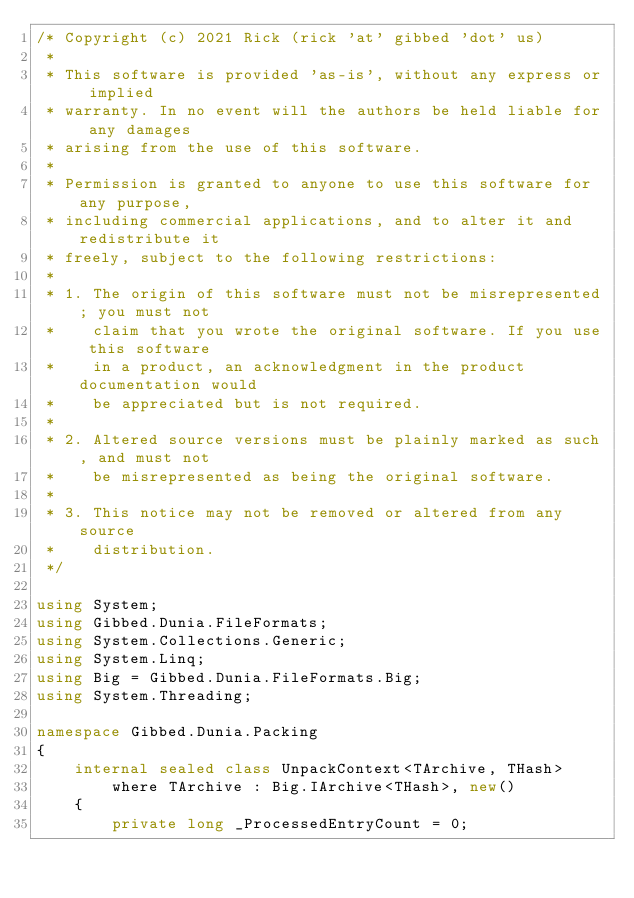<code> <loc_0><loc_0><loc_500><loc_500><_C#_>/* Copyright (c) 2021 Rick (rick 'at' gibbed 'dot' us)
 *
 * This software is provided 'as-is', without any express or implied
 * warranty. In no event will the authors be held liable for any damages
 * arising from the use of this software.
 *
 * Permission is granted to anyone to use this software for any purpose,
 * including commercial applications, and to alter it and redistribute it
 * freely, subject to the following restrictions:
 *
 * 1. The origin of this software must not be misrepresented; you must not
 *    claim that you wrote the original software. If you use this software
 *    in a product, an acknowledgment in the product documentation would
 *    be appreciated but is not required.
 *
 * 2. Altered source versions must be plainly marked as such, and must not
 *    be misrepresented as being the original software.
 *
 * 3. This notice may not be removed or altered from any source
 *    distribution.
 */

using System;
using Gibbed.Dunia.FileFormats;
using System.Collections.Generic;
using System.Linq;
using Big = Gibbed.Dunia.FileFormats.Big;
using System.Threading;

namespace Gibbed.Dunia.Packing
{
    internal sealed class UnpackContext<TArchive, THash>
        where TArchive : Big.IArchive<THash>, new()
    {
        private long _ProcessedEntryCount = 0;
</code> 